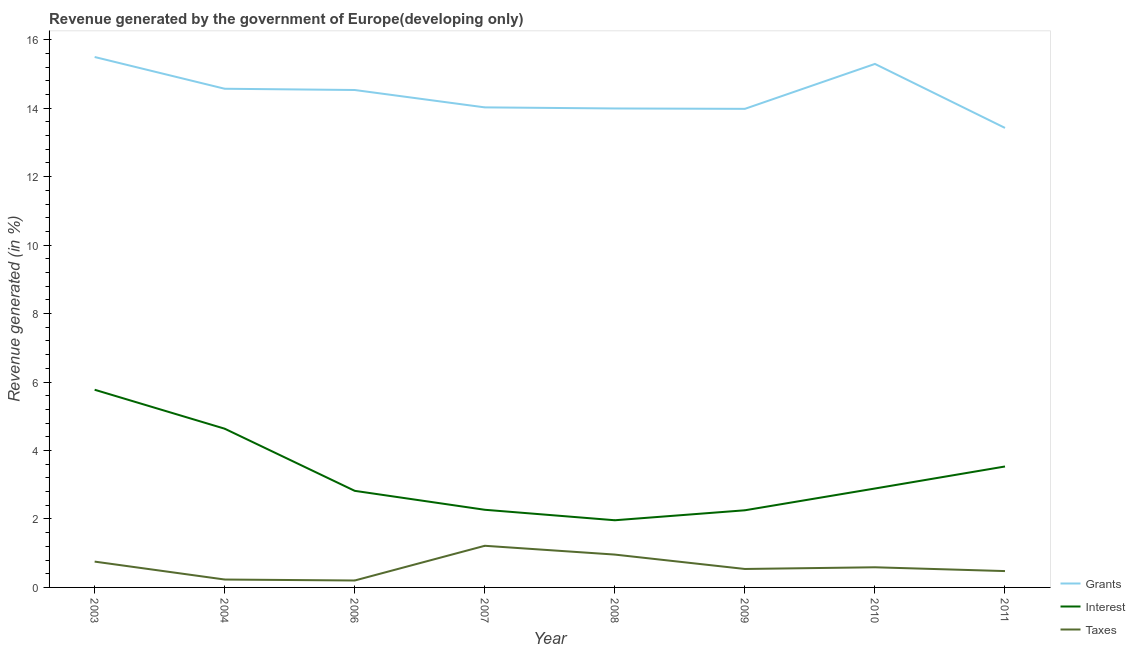What is the percentage of revenue generated by grants in 2004?
Offer a terse response. 14.57. Across all years, what is the maximum percentage of revenue generated by taxes?
Give a very brief answer. 1.22. Across all years, what is the minimum percentage of revenue generated by interest?
Make the answer very short. 1.96. In which year was the percentage of revenue generated by grants maximum?
Provide a short and direct response. 2003. In which year was the percentage of revenue generated by interest minimum?
Your answer should be compact. 2008. What is the total percentage of revenue generated by taxes in the graph?
Give a very brief answer. 4.97. What is the difference between the percentage of revenue generated by taxes in 2004 and that in 2011?
Provide a short and direct response. -0.25. What is the difference between the percentage of revenue generated by taxes in 2007 and the percentage of revenue generated by grants in 2004?
Make the answer very short. -13.35. What is the average percentage of revenue generated by interest per year?
Your answer should be compact. 3.27. In the year 2007, what is the difference between the percentage of revenue generated by interest and percentage of revenue generated by grants?
Your response must be concise. -11.76. What is the ratio of the percentage of revenue generated by grants in 2003 to that in 2011?
Offer a terse response. 1.15. What is the difference between the highest and the second highest percentage of revenue generated by grants?
Provide a succinct answer. 0.2. What is the difference between the highest and the lowest percentage of revenue generated by taxes?
Your answer should be very brief. 1.01. In how many years, is the percentage of revenue generated by interest greater than the average percentage of revenue generated by interest taken over all years?
Provide a succinct answer. 3. Is it the case that in every year, the sum of the percentage of revenue generated by grants and percentage of revenue generated by interest is greater than the percentage of revenue generated by taxes?
Keep it short and to the point. Yes. Is the percentage of revenue generated by interest strictly greater than the percentage of revenue generated by taxes over the years?
Provide a succinct answer. Yes. Is the percentage of revenue generated by taxes strictly less than the percentage of revenue generated by grants over the years?
Your response must be concise. Yes. How many lines are there?
Give a very brief answer. 3. How many years are there in the graph?
Your answer should be very brief. 8. What is the difference between two consecutive major ticks on the Y-axis?
Your response must be concise. 2. Are the values on the major ticks of Y-axis written in scientific E-notation?
Give a very brief answer. No. Does the graph contain grids?
Ensure brevity in your answer.  No. Where does the legend appear in the graph?
Offer a very short reply. Bottom right. What is the title of the graph?
Your response must be concise. Revenue generated by the government of Europe(developing only). Does "Negligence towards kids" appear as one of the legend labels in the graph?
Your answer should be compact. No. What is the label or title of the X-axis?
Provide a succinct answer. Year. What is the label or title of the Y-axis?
Your answer should be very brief. Revenue generated (in %). What is the Revenue generated (in %) in Grants in 2003?
Provide a short and direct response. 15.5. What is the Revenue generated (in %) of Interest in 2003?
Your response must be concise. 5.78. What is the Revenue generated (in %) of Taxes in 2003?
Provide a succinct answer. 0.75. What is the Revenue generated (in %) of Grants in 2004?
Your answer should be compact. 14.57. What is the Revenue generated (in %) of Interest in 2004?
Offer a terse response. 4.64. What is the Revenue generated (in %) of Taxes in 2004?
Offer a terse response. 0.23. What is the Revenue generated (in %) in Grants in 2006?
Make the answer very short. 14.53. What is the Revenue generated (in %) of Interest in 2006?
Your answer should be compact. 2.82. What is the Revenue generated (in %) of Taxes in 2006?
Your response must be concise. 0.2. What is the Revenue generated (in %) of Grants in 2007?
Ensure brevity in your answer.  14.02. What is the Revenue generated (in %) in Interest in 2007?
Offer a terse response. 2.27. What is the Revenue generated (in %) of Taxes in 2007?
Provide a short and direct response. 1.22. What is the Revenue generated (in %) of Grants in 2008?
Keep it short and to the point. 13.99. What is the Revenue generated (in %) in Interest in 2008?
Your answer should be compact. 1.96. What is the Revenue generated (in %) of Taxes in 2008?
Your answer should be compact. 0.96. What is the Revenue generated (in %) in Grants in 2009?
Offer a terse response. 13.98. What is the Revenue generated (in %) of Interest in 2009?
Your answer should be compact. 2.25. What is the Revenue generated (in %) in Taxes in 2009?
Give a very brief answer. 0.54. What is the Revenue generated (in %) of Grants in 2010?
Keep it short and to the point. 15.29. What is the Revenue generated (in %) of Interest in 2010?
Offer a terse response. 2.89. What is the Revenue generated (in %) of Taxes in 2010?
Your answer should be very brief. 0.59. What is the Revenue generated (in %) of Grants in 2011?
Offer a very short reply. 13.42. What is the Revenue generated (in %) in Interest in 2011?
Offer a terse response. 3.53. What is the Revenue generated (in %) in Taxes in 2011?
Your answer should be compact. 0.48. Across all years, what is the maximum Revenue generated (in %) in Grants?
Your answer should be very brief. 15.5. Across all years, what is the maximum Revenue generated (in %) of Interest?
Give a very brief answer. 5.78. Across all years, what is the maximum Revenue generated (in %) of Taxes?
Your answer should be compact. 1.22. Across all years, what is the minimum Revenue generated (in %) in Grants?
Give a very brief answer. 13.42. Across all years, what is the minimum Revenue generated (in %) of Interest?
Provide a short and direct response. 1.96. Across all years, what is the minimum Revenue generated (in %) in Taxes?
Make the answer very short. 0.2. What is the total Revenue generated (in %) of Grants in the graph?
Give a very brief answer. 115.31. What is the total Revenue generated (in %) in Interest in the graph?
Provide a succinct answer. 26.14. What is the total Revenue generated (in %) of Taxes in the graph?
Offer a terse response. 4.97. What is the difference between the Revenue generated (in %) in Grants in 2003 and that in 2004?
Provide a succinct answer. 0.93. What is the difference between the Revenue generated (in %) in Interest in 2003 and that in 2004?
Offer a terse response. 1.14. What is the difference between the Revenue generated (in %) in Taxes in 2003 and that in 2004?
Ensure brevity in your answer.  0.52. What is the difference between the Revenue generated (in %) in Grants in 2003 and that in 2006?
Provide a succinct answer. 0.96. What is the difference between the Revenue generated (in %) of Interest in 2003 and that in 2006?
Keep it short and to the point. 2.95. What is the difference between the Revenue generated (in %) in Taxes in 2003 and that in 2006?
Ensure brevity in your answer.  0.55. What is the difference between the Revenue generated (in %) of Grants in 2003 and that in 2007?
Offer a very short reply. 1.47. What is the difference between the Revenue generated (in %) in Interest in 2003 and that in 2007?
Provide a short and direct response. 3.51. What is the difference between the Revenue generated (in %) in Taxes in 2003 and that in 2007?
Your response must be concise. -0.46. What is the difference between the Revenue generated (in %) in Grants in 2003 and that in 2008?
Provide a short and direct response. 1.5. What is the difference between the Revenue generated (in %) in Interest in 2003 and that in 2008?
Your answer should be compact. 3.81. What is the difference between the Revenue generated (in %) of Taxes in 2003 and that in 2008?
Ensure brevity in your answer.  -0.2. What is the difference between the Revenue generated (in %) of Grants in 2003 and that in 2009?
Your response must be concise. 1.51. What is the difference between the Revenue generated (in %) in Interest in 2003 and that in 2009?
Your answer should be compact. 3.52. What is the difference between the Revenue generated (in %) in Taxes in 2003 and that in 2009?
Give a very brief answer. 0.22. What is the difference between the Revenue generated (in %) in Grants in 2003 and that in 2010?
Your response must be concise. 0.2. What is the difference between the Revenue generated (in %) in Interest in 2003 and that in 2010?
Offer a terse response. 2.89. What is the difference between the Revenue generated (in %) of Taxes in 2003 and that in 2010?
Provide a succinct answer. 0.17. What is the difference between the Revenue generated (in %) in Grants in 2003 and that in 2011?
Your response must be concise. 2.07. What is the difference between the Revenue generated (in %) in Interest in 2003 and that in 2011?
Give a very brief answer. 2.24. What is the difference between the Revenue generated (in %) of Taxes in 2003 and that in 2011?
Give a very brief answer. 0.28. What is the difference between the Revenue generated (in %) of Grants in 2004 and that in 2006?
Give a very brief answer. 0.04. What is the difference between the Revenue generated (in %) of Interest in 2004 and that in 2006?
Your answer should be compact. 1.82. What is the difference between the Revenue generated (in %) in Taxes in 2004 and that in 2006?
Offer a very short reply. 0.03. What is the difference between the Revenue generated (in %) in Grants in 2004 and that in 2007?
Provide a short and direct response. 0.54. What is the difference between the Revenue generated (in %) of Interest in 2004 and that in 2007?
Keep it short and to the point. 2.37. What is the difference between the Revenue generated (in %) in Taxes in 2004 and that in 2007?
Your response must be concise. -0.99. What is the difference between the Revenue generated (in %) in Grants in 2004 and that in 2008?
Ensure brevity in your answer.  0.58. What is the difference between the Revenue generated (in %) in Interest in 2004 and that in 2008?
Make the answer very short. 2.67. What is the difference between the Revenue generated (in %) in Taxes in 2004 and that in 2008?
Offer a terse response. -0.73. What is the difference between the Revenue generated (in %) of Grants in 2004 and that in 2009?
Make the answer very short. 0.59. What is the difference between the Revenue generated (in %) of Interest in 2004 and that in 2009?
Ensure brevity in your answer.  2.38. What is the difference between the Revenue generated (in %) in Taxes in 2004 and that in 2009?
Make the answer very short. -0.31. What is the difference between the Revenue generated (in %) in Grants in 2004 and that in 2010?
Give a very brief answer. -0.72. What is the difference between the Revenue generated (in %) in Interest in 2004 and that in 2010?
Provide a succinct answer. 1.75. What is the difference between the Revenue generated (in %) of Taxes in 2004 and that in 2010?
Make the answer very short. -0.36. What is the difference between the Revenue generated (in %) of Grants in 2004 and that in 2011?
Offer a very short reply. 1.14. What is the difference between the Revenue generated (in %) of Interest in 2004 and that in 2011?
Your answer should be compact. 1.1. What is the difference between the Revenue generated (in %) of Taxes in 2004 and that in 2011?
Your answer should be very brief. -0.25. What is the difference between the Revenue generated (in %) of Grants in 2006 and that in 2007?
Keep it short and to the point. 0.51. What is the difference between the Revenue generated (in %) in Interest in 2006 and that in 2007?
Your answer should be very brief. 0.55. What is the difference between the Revenue generated (in %) of Taxes in 2006 and that in 2007?
Your response must be concise. -1.01. What is the difference between the Revenue generated (in %) of Grants in 2006 and that in 2008?
Offer a very short reply. 0.54. What is the difference between the Revenue generated (in %) in Interest in 2006 and that in 2008?
Make the answer very short. 0.86. What is the difference between the Revenue generated (in %) in Taxes in 2006 and that in 2008?
Provide a short and direct response. -0.76. What is the difference between the Revenue generated (in %) in Grants in 2006 and that in 2009?
Offer a very short reply. 0.55. What is the difference between the Revenue generated (in %) of Interest in 2006 and that in 2009?
Give a very brief answer. 0.57. What is the difference between the Revenue generated (in %) in Taxes in 2006 and that in 2009?
Ensure brevity in your answer.  -0.34. What is the difference between the Revenue generated (in %) in Grants in 2006 and that in 2010?
Make the answer very short. -0.76. What is the difference between the Revenue generated (in %) in Interest in 2006 and that in 2010?
Make the answer very short. -0.07. What is the difference between the Revenue generated (in %) of Taxes in 2006 and that in 2010?
Provide a short and direct response. -0.39. What is the difference between the Revenue generated (in %) in Grants in 2006 and that in 2011?
Provide a succinct answer. 1.11. What is the difference between the Revenue generated (in %) in Interest in 2006 and that in 2011?
Offer a very short reply. -0.71. What is the difference between the Revenue generated (in %) in Taxes in 2006 and that in 2011?
Offer a very short reply. -0.28. What is the difference between the Revenue generated (in %) of Grants in 2007 and that in 2008?
Ensure brevity in your answer.  0.03. What is the difference between the Revenue generated (in %) in Interest in 2007 and that in 2008?
Your response must be concise. 0.31. What is the difference between the Revenue generated (in %) of Taxes in 2007 and that in 2008?
Offer a very short reply. 0.26. What is the difference between the Revenue generated (in %) in Grants in 2007 and that in 2009?
Make the answer very short. 0.04. What is the difference between the Revenue generated (in %) in Interest in 2007 and that in 2009?
Provide a succinct answer. 0.01. What is the difference between the Revenue generated (in %) of Taxes in 2007 and that in 2009?
Your answer should be very brief. 0.68. What is the difference between the Revenue generated (in %) of Grants in 2007 and that in 2010?
Your response must be concise. -1.27. What is the difference between the Revenue generated (in %) in Interest in 2007 and that in 2010?
Provide a succinct answer. -0.62. What is the difference between the Revenue generated (in %) in Taxes in 2007 and that in 2010?
Ensure brevity in your answer.  0.63. What is the difference between the Revenue generated (in %) of Grants in 2007 and that in 2011?
Your answer should be very brief. 0.6. What is the difference between the Revenue generated (in %) of Interest in 2007 and that in 2011?
Offer a terse response. -1.26. What is the difference between the Revenue generated (in %) in Taxes in 2007 and that in 2011?
Offer a very short reply. 0.74. What is the difference between the Revenue generated (in %) of Grants in 2008 and that in 2009?
Provide a short and direct response. 0.01. What is the difference between the Revenue generated (in %) in Interest in 2008 and that in 2009?
Offer a terse response. -0.29. What is the difference between the Revenue generated (in %) in Taxes in 2008 and that in 2009?
Offer a terse response. 0.42. What is the difference between the Revenue generated (in %) in Grants in 2008 and that in 2010?
Provide a succinct answer. -1.3. What is the difference between the Revenue generated (in %) of Interest in 2008 and that in 2010?
Offer a very short reply. -0.93. What is the difference between the Revenue generated (in %) in Taxes in 2008 and that in 2010?
Keep it short and to the point. 0.37. What is the difference between the Revenue generated (in %) of Grants in 2008 and that in 2011?
Give a very brief answer. 0.57. What is the difference between the Revenue generated (in %) in Interest in 2008 and that in 2011?
Provide a succinct answer. -1.57. What is the difference between the Revenue generated (in %) in Taxes in 2008 and that in 2011?
Your answer should be compact. 0.48. What is the difference between the Revenue generated (in %) in Grants in 2009 and that in 2010?
Offer a very short reply. -1.31. What is the difference between the Revenue generated (in %) in Interest in 2009 and that in 2010?
Provide a short and direct response. -0.64. What is the difference between the Revenue generated (in %) in Taxes in 2009 and that in 2010?
Give a very brief answer. -0.05. What is the difference between the Revenue generated (in %) of Grants in 2009 and that in 2011?
Ensure brevity in your answer.  0.56. What is the difference between the Revenue generated (in %) of Interest in 2009 and that in 2011?
Give a very brief answer. -1.28. What is the difference between the Revenue generated (in %) of Taxes in 2009 and that in 2011?
Make the answer very short. 0.06. What is the difference between the Revenue generated (in %) of Grants in 2010 and that in 2011?
Ensure brevity in your answer.  1.87. What is the difference between the Revenue generated (in %) of Interest in 2010 and that in 2011?
Provide a succinct answer. -0.64. What is the difference between the Revenue generated (in %) in Taxes in 2010 and that in 2011?
Offer a very short reply. 0.11. What is the difference between the Revenue generated (in %) in Grants in 2003 and the Revenue generated (in %) in Interest in 2004?
Your answer should be very brief. 10.86. What is the difference between the Revenue generated (in %) of Grants in 2003 and the Revenue generated (in %) of Taxes in 2004?
Make the answer very short. 15.26. What is the difference between the Revenue generated (in %) of Interest in 2003 and the Revenue generated (in %) of Taxes in 2004?
Provide a succinct answer. 5.54. What is the difference between the Revenue generated (in %) of Grants in 2003 and the Revenue generated (in %) of Interest in 2006?
Offer a very short reply. 12.67. What is the difference between the Revenue generated (in %) in Grants in 2003 and the Revenue generated (in %) in Taxes in 2006?
Your answer should be very brief. 15.29. What is the difference between the Revenue generated (in %) in Interest in 2003 and the Revenue generated (in %) in Taxes in 2006?
Provide a short and direct response. 5.57. What is the difference between the Revenue generated (in %) of Grants in 2003 and the Revenue generated (in %) of Interest in 2007?
Offer a very short reply. 13.23. What is the difference between the Revenue generated (in %) of Grants in 2003 and the Revenue generated (in %) of Taxes in 2007?
Your response must be concise. 14.28. What is the difference between the Revenue generated (in %) of Interest in 2003 and the Revenue generated (in %) of Taxes in 2007?
Ensure brevity in your answer.  4.56. What is the difference between the Revenue generated (in %) of Grants in 2003 and the Revenue generated (in %) of Interest in 2008?
Provide a succinct answer. 13.53. What is the difference between the Revenue generated (in %) of Grants in 2003 and the Revenue generated (in %) of Taxes in 2008?
Offer a terse response. 14.54. What is the difference between the Revenue generated (in %) in Interest in 2003 and the Revenue generated (in %) in Taxes in 2008?
Your answer should be compact. 4.82. What is the difference between the Revenue generated (in %) of Grants in 2003 and the Revenue generated (in %) of Interest in 2009?
Offer a terse response. 13.24. What is the difference between the Revenue generated (in %) of Grants in 2003 and the Revenue generated (in %) of Taxes in 2009?
Make the answer very short. 14.96. What is the difference between the Revenue generated (in %) of Interest in 2003 and the Revenue generated (in %) of Taxes in 2009?
Keep it short and to the point. 5.24. What is the difference between the Revenue generated (in %) of Grants in 2003 and the Revenue generated (in %) of Interest in 2010?
Your answer should be very brief. 12.61. What is the difference between the Revenue generated (in %) of Grants in 2003 and the Revenue generated (in %) of Taxes in 2010?
Offer a very short reply. 14.91. What is the difference between the Revenue generated (in %) of Interest in 2003 and the Revenue generated (in %) of Taxes in 2010?
Your response must be concise. 5.19. What is the difference between the Revenue generated (in %) of Grants in 2003 and the Revenue generated (in %) of Interest in 2011?
Your answer should be very brief. 11.96. What is the difference between the Revenue generated (in %) in Grants in 2003 and the Revenue generated (in %) in Taxes in 2011?
Ensure brevity in your answer.  15.02. What is the difference between the Revenue generated (in %) of Interest in 2003 and the Revenue generated (in %) of Taxes in 2011?
Provide a succinct answer. 5.3. What is the difference between the Revenue generated (in %) in Grants in 2004 and the Revenue generated (in %) in Interest in 2006?
Keep it short and to the point. 11.75. What is the difference between the Revenue generated (in %) of Grants in 2004 and the Revenue generated (in %) of Taxes in 2006?
Your answer should be compact. 14.37. What is the difference between the Revenue generated (in %) in Interest in 2004 and the Revenue generated (in %) in Taxes in 2006?
Offer a very short reply. 4.43. What is the difference between the Revenue generated (in %) of Grants in 2004 and the Revenue generated (in %) of Interest in 2007?
Ensure brevity in your answer.  12.3. What is the difference between the Revenue generated (in %) in Grants in 2004 and the Revenue generated (in %) in Taxes in 2007?
Your answer should be compact. 13.35. What is the difference between the Revenue generated (in %) in Interest in 2004 and the Revenue generated (in %) in Taxes in 2007?
Your answer should be compact. 3.42. What is the difference between the Revenue generated (in %) in Grants in 2004 and the Revenue generated (in %) in Interest in 2008?
Ensure brevity in your answer.  12.61. What is the difference between the Revenue generated (in %) of Grants in 2004 and the Revenue generated (in %) of Taxes in 2008?
Provide a short and direct response. 13.61. What is the difference between the Revenue generated (in %) in Interest in 2004 and the Revenue generated (in %) in Taxes in 2008?
Your answer should be very brief. 3.68. What is the difference between the Revenue generated (in %) of Grants in 2004 and the Revenue generated (in %) of Interest in 2009?
Your answer should be compact. 12.31. What is the difference between the Revenue generated (in %) of Grants in 2004 and the Revenue generated (in %) of Taxes in 2009?
Your answer should be very brief. 14.03. What is the difference between the Revenue generated (in %) of Interest in 2004 and the Revenue generated (in %) of Taxes in 2009?
Your answer should be compact. 4.1. What is the difference between the Revenue generated (in %) of Grants in 2004 and the Revenue generated (in %) of Interest in 2010?
Your answer should be very brief. 11.68. What is the difference between the Revenue generated (in %) in Grants in 2004 and the Revenue generated (in %) in Taxes in 2010?
Offer a terse response. 13.98. What is the difference between the Revenue generated (in %) of Interest in 2004 and the Revenue generated (in %) of Taxes in 2010?
Keep it short and to the point. 4.05. What is the difference between the Revenue generated (in %) in Grants in 2004 and the Revenue generated (in %) in Interest in 2011?
Provide a short and direct response. 11.03. What is the difference between the Revenue generated (in %) in Grants in 2004 and the Revenue generated (in %) in Taxes in 2011?
Provide a short and direct response. 14.09. What is the difference between the Revenue generated (in %) of Interest in 2004 and the Revenue generated (in %) of Taxes in 2011?
Keep it short and to the point. 4.16. What is the difference between the Revenue generated (in %) in Grants in 2006 and the Revenue generated (in %) in Interest in 2007?
Your answer should be compact. 12.26. What is the difference between the Revenue generated (in %) in Grants in 2006 and the Revenue generated (in %) in Taxes in 2007?
Your answer should be very brief. 13.31. What is the difference between the Revenue generated (in %) of Interest in 2006 and the Revenue generated (in %) of Taxes in 2007?
Your answer should be very brief. 1.6. What is the difference between the Revenue generated (in %) in Grants in 2006 and the Revenue generated (in %) in Interest in 2008?
Your answer should be compact. 12.57. What is the difference between the Revenue generated (in %) in Grants in 2006 and the Revenue generated (in %) in Taxes in 2008?
Offer a very short reply. 13.57. What is the difference between the Revenue generated (in %) of Interest in 2006 and the Revenue generated (in %) of Taxes in 2008?
Ensure brevity in your answer.  1.86. What is the difference between the Revenue generated (in %) in Grants in 2006 and the Revenue generated (in %) in Interest in 2009?
Provide a succinct answer. 12.28. What is the difference between the Revenue generated (in %) of Grants in 2006 and the Revenue generated (in %) of Taxes in 2009?
Ensure brevity in your answer.  13.99. What is the difference between the Revenue generated (in %) in Interest in 2006 and the Revenue generated (in %) in Taxes in 2009?
Provide a short and direct response. 2.28. What is the difference between the Revenue generated (in %) of Grants in 2006 and the Revenue generated (in %) of Interest in 2010?
Offer a terse response. 11.64. What is the difference between the Revenue generated (in %) of Grants in 2006 and the Revenue generated (in %) of Taxes in 2010?
Your answer should be compact. 13.94. What is the difference between the Revenue generated (in %) of Interest in 2006 and the Revenue generated (in %) of Taxes in 2010?
Provide a short and direct response. 2.23. What is the difference between the Revenue generated (in %) of Grants in 2006 and the Revenue generated (in %) of Interest in 2011?
Give a very brief answer. 11. What is the difference between the Revenue generated (in %) in Grants in 2006 and the Revenue generated (in %) in Taxes in 2011?
Your response must be concise. 14.05. What is the difference between the Revenue generated (in %) of Interest in 2006 and the Revenue generated (in %) of Taxes in 2011?
Your answer should be very brief. 2.34. What is the difference between the Revenue generated (in %) of Grants in 2007 and the Revenue generated (in %) of Interest in 2008?
Provide a succinct answer. 12.06. What is the difference between the Revenue generated (in %) in Grants in 2007 and the Revenue generated (in %) in Taxes in 2008?
Your answer should be very brief. 13.06. What is the difference between the Revenue generated (in %) of Interest in 2007 and the Revenue generated (in %) of Taxes in 2008?
Offer a terse response. 1.31. What is the difference between the Revenue generated (in %) of Grants in 2007 and the Revenue generated (in %) of Interest in 2009?
Ensure brevity in your answer.  11.77. What is the difference between the Revenue generated (in %) of Grants in 2007 and the Revenue generated (in %) of Taxes in 2009?
Ensure brevity in your answer.  13.48. What is the difference between the Revenue generated (in %) in Interest in 2007 and the Revenue generated (in %) in Taxes in 2009?
Your answer should be compact. 1.73. What is the difference between the Revenue generated (in %) of Grants in 2007 and the Revenue generated (in %) of Interest in 2010?
Your answer should be compact. 11.13. What is the difference between the Revenue generated (in %) of Grants in 2007 and the Revenue generated (in %) of Taxes in 2010?
Keep it short and to the point. 13.44. What is the difference between the Revenue generated (in %) in Interest in 2007 and the Revenue generated (in %) in Taxes in 2010?
Your response must be concise. 1.68. What is the difference between the Revenue generated (in %) in Grants in 2007 and the Revenue generated (in %) in Interest in 2011?
Provide a short and direct response. 10.49. What is the difference between the Revenue generated (in %) in Grants in 2007 and the Revenue generated (in %) in Taxes in 2011?
Your answer should be compact. 13.55. What is the difference between the Revenue generated (in %) in Interest in 2007 and the Revenue generated (in %) in Taxes in 2011?
Offer a terse response. 1.79. What is the difference between the Revenue generated (in %) of Grants in 2008 and the Revenue generated (in %) of Interest in 2009?
Ensure brevity in your answer.  11.74. What is the difference between the Revenue generated (in %) in Grants in 2008 and the Revenue generated (in %) in Taxes in 2009?
Offer a terse response. 13.45. What is the difference between the Revenue generated (in %) of Interest in 2008 and the Revenue generated (in %) of Taxes in 2009?
Offer a very short reply. 1.42. What is the difference between the Revenue generated (in %) of Grants in 2008 and the Revenue generated (in %) of Interest in 2010?
Keep it short and to the point. 11.1. What is the difference between the Revenue generated (in %) of Grants in 2008 and the Revenue generated (in %) of Taxes in 2010?
Keep it short and to the point. 13.4. What is the difference between the Revenue generated (in %) in Interest in 2008 and the Revenue generated (in %) in Taxes in 2010?
Give a very brief answer. 1.37. What is the difference between the Revenue generated (in %) of Grants in 2008 and the Revenue generated (in %) of Interest in 2011?
Your response must be concise. 10.46. What is the difference between the Revenue generated (in %) of Grants in 2008 and the Revenue generated (in %) of Taxes in 2011?
Ensure brevity in your answer.  13.51. What is the difference between the Revenue generated (in %) of Interest in 2008 and the Revenue generated (in %) of Taxes in 2011?
Make the answer very short. 1.49. What is the difference between the Revenue generated (in %) in Grants in 2009 and the Revenue generated (in %) in Interest in 2010?
Provide a succinct answer. 11.09. What is the difference between the Revenue generated (in %) of Grants in 2009 and the Revenue generated (in %) of Taxes in 2010?
Keep it short and to the point. 13.39. What is the difference between the Revenue generated (in %) in Interest in 2009 and the Revenue generated (in %) in Taxes in 2010?
Make the answer very short. 1.67. What is the difference between the Revenue generated (in %) of Grants in 2009 and the Revenue generated (in %) of Interest in 2011?
Your answer should be very brief. 10.45. What is the difference between the Revenue generated (in %) in Grants in 2009 and the Revenue generated (in %) in Taxes in 2011?
Your response must be concise. 13.5. What is the difference between the Revenue generated (in %) in Interest in 2009 and the Revenue generated (in %) in Taxes in 2011?
Your response must be concise. 1.78. What is the difference between the Revenue generated (in %) in Grants in 2010 and the Revenue generated (in %) in Interest in 2011?
Ensure brevity in your answer.  11.76. What is the difference between the Revenue generated (in %) of Grants in 2010 and the Revenue generated (in %) of Taxes in 2011?
Keep it short and to the point. 14.82. What is the difference between the Revenue generated (in %) in Interest in 2010 and the Revenue generated (in %) in Taxes in 2011?
Give a very brief answer. 2.41. What is the average Revenue generated (in %) in Grants per year?
Provide a succinct answer. 14.41. What is the average Revenue generated (in %) of Interest per year?
Your answer should be compact. 3.27. What is the average Revenue generated (in %) in Taxes per year?
Provide a short and direct response. 0.62. In the year 2003, what is the difference between the Revenue generated (in %) in Grants and Revenue generated (in %) in Interest?
Your answer should be compact. 9.72. In the year 2003, what is the difference between the Revenue generated (in %) in Grants and Revenue generated (in %) in Taxes?
Offer a very short reply. 14.74. In the year 2003, what is the difference between the Revenue generated (in %) in Interest and Revenue generated (in %) in Taxes?
Ensure brevity in your answer.  5.02. In the year 2004, what is the difference between the Revenue generated (in %) of Grants and Revenue generated (in %) of Interest?
Your answer should be very brief. 9.93. In the year 2004, what is the difference between the Revenue generated (in %) of Grants and Revenue generated (in %) of Taxes?
Make the answer very short. 14.34. In the year 2004, what is the difference between the Revenue generated (in %) in Interest and Revenue generated (in %) in Taxes?
Your answer should be very brief. 4.41. In the year 2006, what is the difference between the Revenue generated (in %) in Grants and Revenue generated (in %) in Interest?
Your answer should be compact. 11.71. In the year 2006, what is the difference between the Revenue generated (in %) in Grants and Revenue generated (in %) in Taxes?
Provide a succinct answer. 14.33. In the year 2006, what is the difference between the Revenue generated (in %) in Interest and Revenue generated (in %) in Taxes?
Your answer should be compact. 2.62. In the year 2007, what is the difference between the Revenue generated (in %) in Grants and Revenue generated (in %) in Interest?
Provide a succinct answer. 11.76. In the year 2007, what is the difference between the Revenue generated (in %) of Grants and Revenue generated (in %) of Taxes?
Offer a terse response. 12.81. In the year 2007, what is the difference between the Revenue generated (in %) of Interest and Revenue generated (in %) of Taxes?
Offer a very short reply. 1.05. In the year 2008, what is the difference between the Revenue generated (in %) of Grants and Revenue generated (in %) of Interest?
Make the answer very short. 12.03. In the year 2008, what is the difference between the Revenue generated (in %) of Grants and Revenue generated (in %) of Taxes?
Give a very brief answer. 13.03. In the year 2009, what is the difference between the Revenue generated (in %) in Grants and Revenue generated (in %) in Interest?
Provide a succinct answer. 11.73. In the year 2009, what is the difference between the Revenue generated (in %) of Grants and Revenue generated (in %) of Taxes?
Your response must be concise. 13.44. In the year 2009, what is the difference between the Revenue generated (in %) in Interest and Revenue generated (in %) in Taxes?
Your response must be concise. 1.71. In the year 2010, what is the difference between the Revenue generated (in %) in Grants and Revenue generated (in %) in Interest?
Your response must be concise. 12.4. In the year 2010, what is the difference between the Revenue generated (in %) of Grants and Revenue generated (in %) of Taxes?
Provide a short and direct response. 14.7. In the year 2010, what is the difference between the Revenue generated (in %) in Interest and Revenue generated (in %) in Taxes?
Keep it short and to the point. 2.3. In the year 2011, what is the difference between the Revenue generated (in %) of Grants and Revenue generated (in %) of Interest?
Your answer should be compact. 9.89. In the year 2011, what is the difference between the Revenue generated (in %) in Grants and Revenue generated (in %) in Taxes?
Your answer should be compact. 12.95. In the year 2011, what is the difference between the Revenue generated (in %) in Interest and Revenue generated (in %) in Taxes?
Provide a succinct answer. 3.06. What is the ratio of the Revenue generated (in %) of Grants in 2003 to that in 2004?
Make the answer very short. 1.06. What is the ratio of the Revenue generated (in %) of Interest in 2003 to that in 2004?
Ensure brevity in your answer.  1.25. What is the ratio of the Revenue generated (in %) in Taxes in 2003 to that in 2004?
Offer a very short reply. 3.27. What is the ratio of the Revenue generated (in %) in Grants in 2003 to that in 2006?
Offer a terse response. 1.07. What is the ratio of the Revenue generated (in %) of Interest in 2003 to that in 2006?
Your answer should be very brief. 2.05. What is the ratio of the Revenue generated (in %) in Taxes in 2003 to that in 2006?
Provide a short and direct response. 3.73. What is the ratio of the Revenue generated (in %) of Grants in 2003 to that in 2007?
Give a very brief answer. 1.1. What is the ratio of the Revenue generated (in %) in Interest in 2003 to that in 2007?
Make the answer very short. 2.55. What is the ratio of the Revenue generated (in %) of Taxes in 2003 to that in 2007?
Make the answer very short. 0.62. What is the ratio of the Revenue generated (in %) of Grants in 2003 to that in 2008?
Give a very brief answer. 1.11. What is the ratio of the Revenue generated (in %) of Interest in 2003 to that in 2008?
Ensure brevity in your answer.  2.94. What is the ratio of the Revenue generated (in %) in Taxes in 2003 to that in 2008?
Ensure brevity in your answer.  0.79. What is the ratio of the Revenue generated (in %) in Grants in 2003 to that in 2009?
Provide a succinct answer. 1.11. What is the ratio of the Revenue generated (in %) of Interest in 2003 to that in 2009?
Ensure brevity in your answer.  2.56. What is the ratio of the Revenue generated (in %) of Taxes in 2003 to that in 2009?
Provide a short and direct response. 1.4. What is the ratio of the Revenue generated (in %) of Grants in 2003 to that in 2010?
Offer a terse response. 1.01. What is the ratio of the Revenue generated (in %) in Interest in 2003 to that in 2010?
Make the answer very short. 2. What is the ratio of the Revenue generated (in %) in Taxes in 2003 to that in 2010?
Make the answer very short. 1.28. What is the ratio of the Revenue generated (in %) of Grants in 2003 to that in 2011?
Provide a short and direct response. 1.15. What is the ratio of the Revenue generated (in %) in Interest in 2003 to that in 2011?
Provide a succinct answer. 1.63. What is the ratio of the Revenue generated (in %) in Taxes in 2003 to that in 2011?
Offer a terse response. 1.58. What is the ratio of the Revenue generated (in %) in Grants in 2004 to that in 2006?
Make the answer very short. 1. What is the ratio of the Revenue generated (in %) in Interest in 2004 to that in 2006?
Give a very brief answer. 1.64. What is the ratio of the Revenue generated (in %) of Taxes in 2004 to that in 2006?
Keep it short and to the point. 1.14. What is the ratio of the Revenue generated (in %) in Grants in 2004 to that in 2007?
Provide a succinct answer. 1.04. What is the ratio of the Revenue generated (in %) in Interest in 2004 to that in 2007?
Your response must be concise. 2.04. What is the ratio of the Revenue generated (in %) in Taxes in 2004 to that in 2007?
Ensure brevity in your answer.  0.19. What is the ratio of the Revenue generated (in %) of Grants in 2004 to that in 2008?
Your answer should be compact. 1.04. What is the ratio of the Revenue generated (in %) of Interest in 2004 to that in 2008?
Provide a short and direct response. 2.36. What is the ratio of the Revenue generated (in %) of Taxes in 2004 to that in 2008?
Offer a very short reply. 0.24. What is the ratio of the Revenue generated (in %) of Grants in 2004 to that in 2009?
Offer a terse response. 1.04. What is the ratio of the Revenue generated (in %) of Interest in 2004 to that in 2009?
Provide a succinct answer. 2.06. What is the ratio of the Revenue generated (in %) in Taxes in 2004 to that in 2009?
Ensure brevity in your answer.  0.43. What is the ratio of the Revenue generated (in %) of Grants in 2004 to that in 2010?
Your response must be concise. 0.95. What is the ratio of the Revenue generated (in %) of Interest in 2004 to that in 2010?
Provide a succinct answer. 1.6. What is the ratio of the Revenue generated (in %) of Taxes in 2004 to that in 2010?
Provide a short and direct response. 0.39. What is the ratio of the Revenue generated (in %) of Grants in 2004 to that in 2011?
Offer a terse response. 1.09. What is the ratio of the Revenue generated (in %) of Interest in 2004 to that in 2011?
Keep it short and to the point. 1.31. What is the ratio of the Revenue generated (in %) of Taxes in 2004 to that in 2011?
Offer a terse response. 0.48. What is the ratio of the Revenue generated (in %) of Grants in 2006 to that in 2007?
Give a very brief answer. 1.04. What is the ratio of the Revenue generated (in %) of Interest in 2006 to that in 2007?
Keep it short and to the point. 1.24. What is the ratio of the Revenue generated (in %) of Taxes in 2006 to that in 2007?
Your response must be concise. 0.17. What is the ratio of the Revenue generated (in %) of Grants in 2006 to that in 2008?
Provide a succinct answer. 1.04. What is the ratio of the Revenue generated (in %) in Interest in 2006 to that in 2008?
Your answer should be very brief. 1.44. What is the ratio of the Revenue generated (in %) in Taxes in 2006 to that in 2008?
Offer a terse response. 0.21. What is the ratio of the Revenue generated (in %) in Grants in 2006 to that in 2009?
Your answer should be compact. 1.04. What is the ratio of the Revenue generated (in %) in Interest in 2006 to that in 2009?
Give a very brief answer. 1.25. What is the ratio of the Revenue generated (in %) in Taxes in 2006 to that in 2009?
Make the answer very short. 0.38. What is the ratio of the Revenue generated (in %) in Grants in 2006 to that in 2010?
Make the answer very short. 0.95. What is the ratio of the Revenue generated (in %) of Interest in 2006 to that in 2010?
Offer a terse response. 0.98. What is the ratio of the Revenue generated (in %) in Taxes in 2006 to that in 2010?
Ensure brevity in your answer.  0.34. What is the ratio of the Revenue generated (in %) in Grants in 2006 to that in 2011?
Give a very brief answer. 1.08. What is the ratio of the Revenue generated (in %) in Interest in 2006 to that in 2011?
Ensure brevity in your answer.  0.8. What is the ratio of the Revenue generated (in %) of Taxes in 2006 to that in 2011?
Keep it short and to the point. 0.42. What is the ratio of the Revenue generated (in %) of Interest in 2007 to that in 2008?
Your answer should be very brief. 1.16. What is the ratio of the Revenue generated (in %) in Taxes in 2007 to that in 2008?
Provide a succinct answer. 1.27. What is the ratio of the Revenue generated (in %) in Interest in 2007 to that in 2009?
Your answer should be compact. 1.01. What is the ratio of the Revenue generated (in %) of Taxes in 2007 to that in 2009?
Offer a terse response. 2.26. What is the ratio of the Revenue generated (in %) in Grants in 2007 to that in 2010?
Offer a terse response. 0.92. What is the ratio of the Revenue generated (in %) in Interest in 2007 to that in 2010?
Your answer should be compact. 0.79. What is the ratio of the Revenue generated (in %) of Taxes in 2007 to that in 2010?
Make the answer very short. 2.07. What is the ratio of the Revenue generated (in %) of Grants in 2007 to that in 2011?
Your answer should be compact. 1.04. What is the ratio of the Revenue generated (in %) of Interest in 2007 to that in 2011?
Ensure brevity in your answer.  0.64. What is the ratio of the Revenue generated (in %) of Taxes in 2007 to that in 2011?
Keep it short and to the point. 2.55. What is the ratio of the Revenue generated (in %) in Interest in 2008 to that in 2009?
Your response must be concise. 0.87. What is the ratio of the Revenue generated (in %) in Taxes in 2008 to that in 2009?
Your answer should be very brief. 1.78. What is the ratio of the Revenue generated (in %) of Grants in 2008 to that in 2010?
Offer a very short reply. 0.91. What is the ratio of the Revenue generated (in %) of Interest in 2008 to that in 2010?
Your answer should be compact. 0.68. What is the ratio of the Revenue generated (in %) in Taxes in 2008 to that in 2010?
Your answer should be very brief. 1.63. What is the ratio of the Revenue generated (in %) of Grants in 2008 to that in 2011?
Provide a succinct answer. 1.04. What is the ratio of the Revenue generated (in %) of Interest in 2008 to that in 2011?
Provide a succinct answer. 0.56. What is the ratio of the Revenue generated (in %) in Taxes in 2008 to that in 2011?
Your response must be concise. 2.01. What is the ratio of the Revenue generated (in %) in Grants in 2009 to that in 2010?
Make the answer very short. 0.91. What is the ratio of the Revenue generated (in %) of Interest in 2009 to that in 2010?
Offer a very short reply. 0.78. What is the ratio of the Revenue generated (in %) of Taxes in 2009 to that in 2010?
Provide a succinct answer. 0.92. What is the ratio of the Revenue generated (in %) of Grants in 2009 to that in 2011?
Make the answer very short. 1.04. What is the ratio of the Revenue generated (in %) of Interest in 2009 to that in 2011?
Offer a terse response. 0.64. What is the ratio of the Revenue generated (in %) in Taxes in 2009 to that in 2011?
Your response must be concise. 1.13. What is the ratio of the Revenue generated (in %) of Grants in 2010 to that in 2011?
Make the answer very short. 1.14. What is the ratio of the Revenue generated (in %) in Interest in 2010 to that in 2011?
Your answer should be compact. 0.82. What is the ratio of the Revenue generated (in %) in Taxes in 2010 to that in 2011?
Ensure brevity in your answer.  1.23. What is the difference between the highest and the second highest Revenue generated (in %) of Grants?
Offer a very short reply. 0.2. What is the difference between the highest and the second highest Revenue generated (in %) in Interest?
Keep it short and to the point. 1.14. What is the difference between the highest and the second highest Revenue generated (in %) of Taxes?
Keep it short and to the point. 0.26. What is the difference between the highest and the lowest Revenue generated (in %) in Grants?
Keep it short and to the point. 2.07. What is the difference between the highest and the lowest Revenue generated (in %) in Interest?
Make the answer very short. 3.81. What is the difference between the highest and the lowest Revenue generated (in %) of Taxes?
Keep it short and to the point. 1.01. 